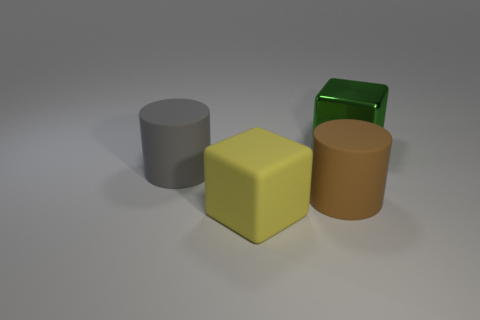How do the shapes of the objects contribute to the composition of the image? The composition of the image is an interesting interplay of basic geometric shapes. The cylinder, cube, and two rectangular prisms offer a study in contrast and arrangement. The round edges of the cylinder offset the sharp corners of the cubes, creating visual interest. Their placement, with varying sizes and an asymmetrical balance, engages the viewer’s eye and draws attention to the central yellow cube. 